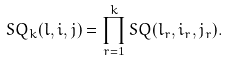Convert formula to latex. <formula><loc_0><loc_0><loc_500><loc_500>S Q _ { k } ( l , i , j ) = \prod _ { r = 1 } ^ { k } S Q ( l _ { r } , i _ { r } , j _ { r } ) .</formula> 